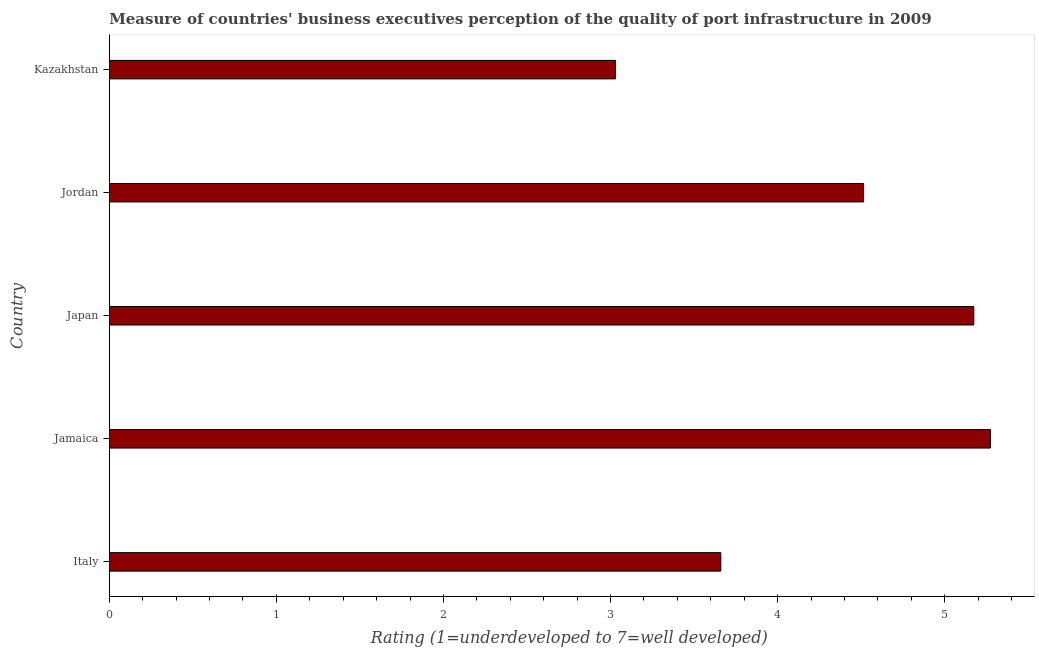Does the graph contain any zero values?
Ensure brevity in your answer.  No. What is the title of the graph?
Make the answer very short. Measure of countries' business executives perception of the quality of port infrastructure in 2009. What is the label or title of the X-axis?
Your answer should be compact. Rating (1=underdeveloped to 7=well developed) . What is the rating measuring quality of port infrastructure in Kazakhstan?
Your response must be concise. 3.03. Across all countries, what is the maximum rating measuring quality of port infrastructure?
Your answer should be very brief. 5.27. Across all countries, what is the minimum rating measuring quality of port infrastructure?
Provide a short and direct response. 3.03. In which country was the rating measuring quality of port infrastructure maximum?
Keep it short and to the point. Jamaica. In which country was the rating measuring quality of port infrastructure minimum?
Your response must be concise. Kazakhstan. What is the sum of the rating measuring quality of port infrastructure?
Your response must be concise. 21.65. What is the difference between the rating measuring quality of port infrastructure in Jamaica and Jordan?
Give a very brief answer. 0.76. What is the average rating measuring quality of port infrastructure per country?
Offer a terse response. 4.33. What is the median rating measuring quality of port infrastructure?
Offer a very short reply. 4.51. What is the ratio of the rating measuring quality of port infrastructure in Japan to that in Jordan?
Provide a short and direct response. 1.15. Is the rating measuring quality of port infrastructure in Italy less than that in Japan?
Provide a short and direct response. Yes. Is the difference between the rating measuring quality of port infrastructure in Italy and Jordan greater than the difference between any two countries?
Offer a very short reply. No. What is the difference between the highest and the lowest rating measuring quality of port infrastructure?
Offer a terse response. 2.24. In how many countries, is the rating measuring quality of port infrastructure greater than the average rating measuring quality of port infrastructure taken over all countries?
Provide a succinct answer. 3. Are all the bars in the graph horizontal?
Keep it short and to the point. Yes. Are the values on the major ticks of X-axis written in scientific E-notation?
Keep it short and to the point. No. What is the Rating (1=underdeveloped to 7=well developed)  in Italy?
Your response must be concise. 3.66. What is the Rating (1=underdeveloped to 7=well developed)  in Jamaica?
Keep it short and to the point. 5.27. What is the Rating (1=underdeveloped to 7=well developed)  of Japan?
Ensure brevity in your answer.  5.17. What is the Rating (1=underdeveloped to 7=well developed)  in Jordan?
Give a very brief answer. 4.51. What is the Rating (1=underdeveloped to 7=well developed)  in Kazakhstan?
Make the answer very short. 3.03. What is the difference between the Rating (1=underdeveloped to 7=well developed)  in Italy and Jamaica?
Make the answer very short. -1.61. What is the difference between the Rating (1=underdeveloped to 7=well developed)  in Italy and Japan?
Offer a very short reply. -1.51. What is the difference between the Rating (1=underdeveloped to 7=well developed)  in Italy and Jordan?
Your answer should be very brief. -0.85. What is the difference between the Rating (1=underdeveloped to 7=well developed)  in Italy and Kazakhstan?
Ensure brevity in your answer.  0.63. What is the difference between the Rating (1=underdeveloped to 7=well developed)  in Jamaica and Japan?
Make the answer very short. 0.1. What is the difference between the Rating (1=underdeveloped to 7=well developed)  in Jamaica and Jordan?
Offer a very short reply. 0.76. What is the difference between the Rating (1=underdeveloped to 7=well developed)  in Jamaica and Kazakhstan?
Provide a short and direct response. 2.24. What is the difference between the Rating (1=underdeveloped to 7=well developed)  in Japan and Jordan?
Offer a terse response. 0.66. What is the difference between the Rating (1=underdeveloped to 7=well developed)  in Japan and Kazakhstan?
Provide a succinct answer. 2.14. What is the difference between the Rating (1=underdeveloped to 7=well developed)  in Jordan and Kazakhstan?
Your response must be concise. 1.48. What is the ratio of the Rating (1=underdeveloped to 7=well developed)  in Italy to that in Jamaica?
Provide a succinct answer. 0.69. What is the ratio of the Rating (1=underdeveloped to 7=well developed)  in Italy to that in Japan?
Provide a succinct answer. 0.71. What is the ratio of the Rating (1=underdeveloped to 7=well developed)  in Italy to that in Jordan?
Provide a short and direct response. 0.81. What is the ratio of the Rating (1=underdeveloped to 7=well developed)  in Italy to that in Kazakhstan?
Give a very brief answer. 1.21. What is the ratio of the Rating (1=underdeveloped to 7=well developed)  in Jamaica to that in Japan?
Offer a terse response. 1.02. What is the ratio of the Rating (1=underdeveloped to 7=well developed)  in Jamaica to that in Jordan?
Your answer should be very brief. 1.17. What is the ratio of the Rating (1=underdeveloped to 7=well developed)  in Jamaica to that in Kazakhstan?
Your answer should be compact. 1.74. What is the ratio of the Rating (1=underdeveloped to 7=well developed)  in Japan to that in Jordan?
Keep it short and to the point. 1.15. What is the ratio of the Rating (1=underdeveloped to 7=well developed)  in Japan to that in Kazakhstan?
Provide a short and direct response. 1.71. What is the ratio of the Rating (1=underdeveloped to 7=well developed)  in Jordan to that in Kazakhstan?
Your answer should be compact. 1.49. 